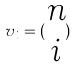<formula> <loc_0><loc_0><loc_500><loc_500>v _ { i } = ( \begin{matrix} n \\ i \end{matrix} )</formula> 